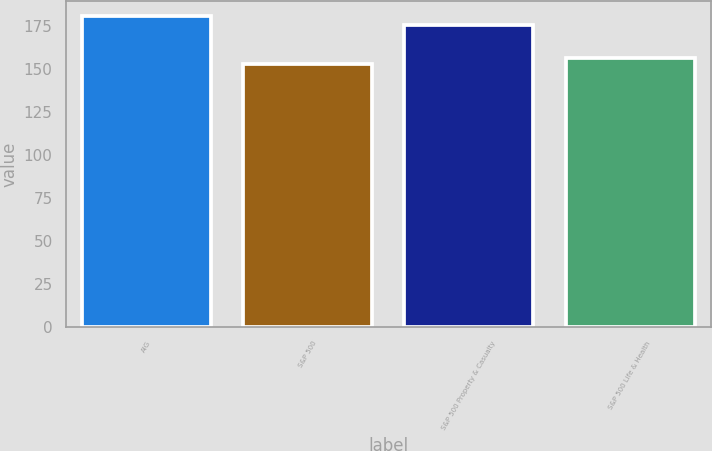Convert chart to OTSL. <chart><loc_0><loc_0><loc_500><loc_500><bar_chart><fcel>AIG<fcel>S&P 500<fcel>S&P 500 Property & Casualty<fcel>S&P 500 Life & Health<nl><fcel>180.37<fcel>152.59<fcel>175.32<fcel>156.14<nl></chart> 